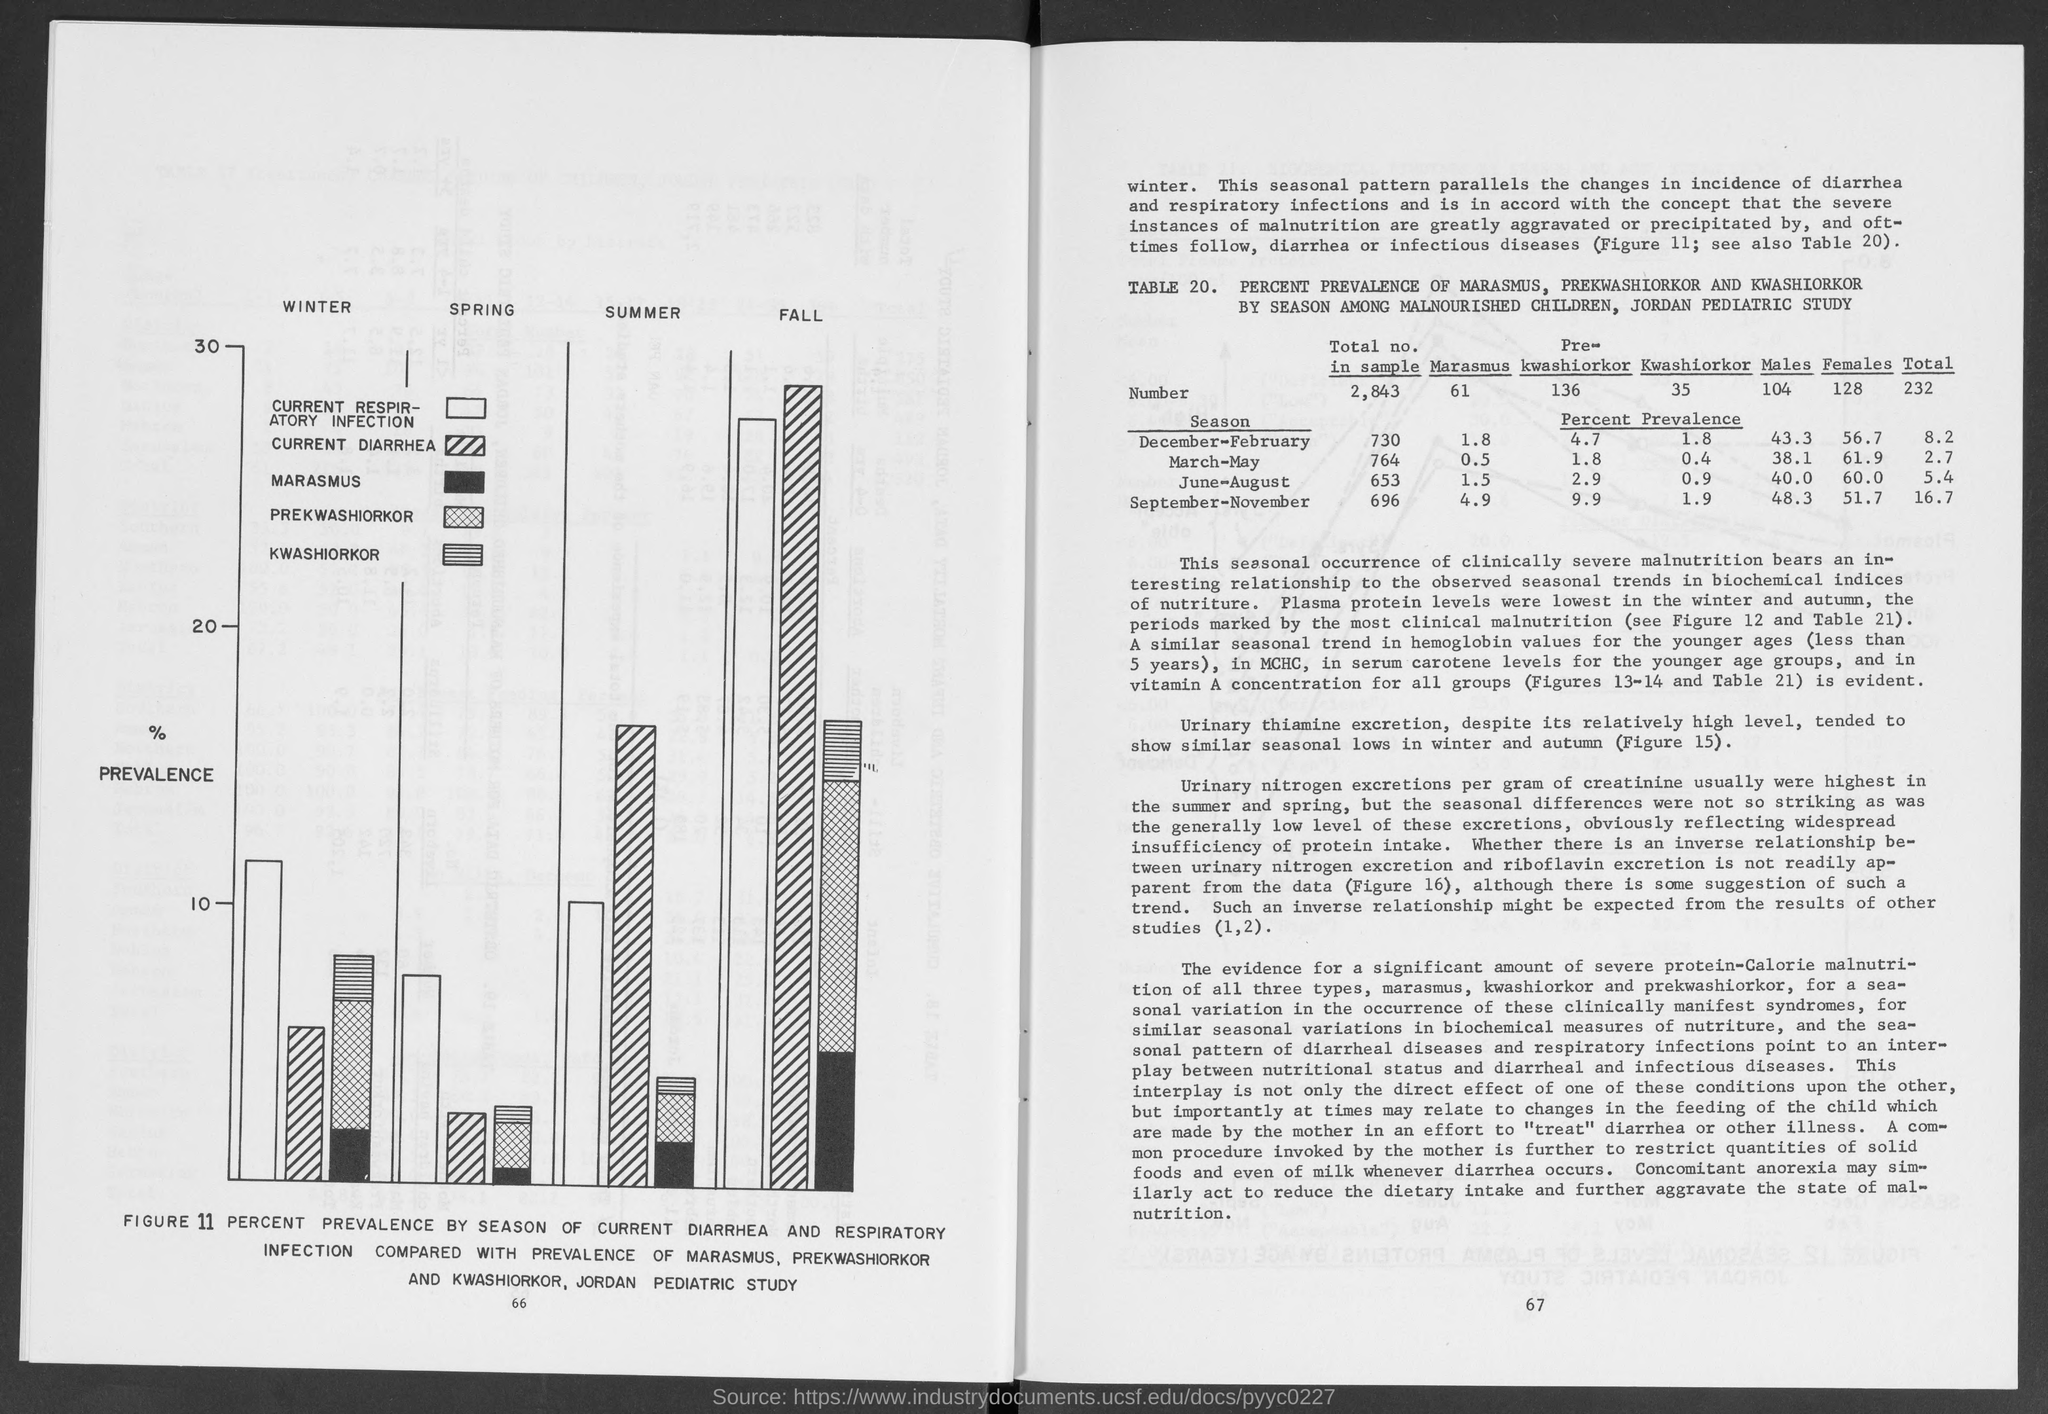Indicate a few pertinent items in this graphic. Percent prevalence of kwashiorkor in the September-November season is 1.9%. The prevalence of males in the June-August season is 40.0%. The prevalence of pre-Kwashiorkor in the June-August season is 2.9%. The total number of cases of marasmus was 61. The total number in the sample was 2,843. 